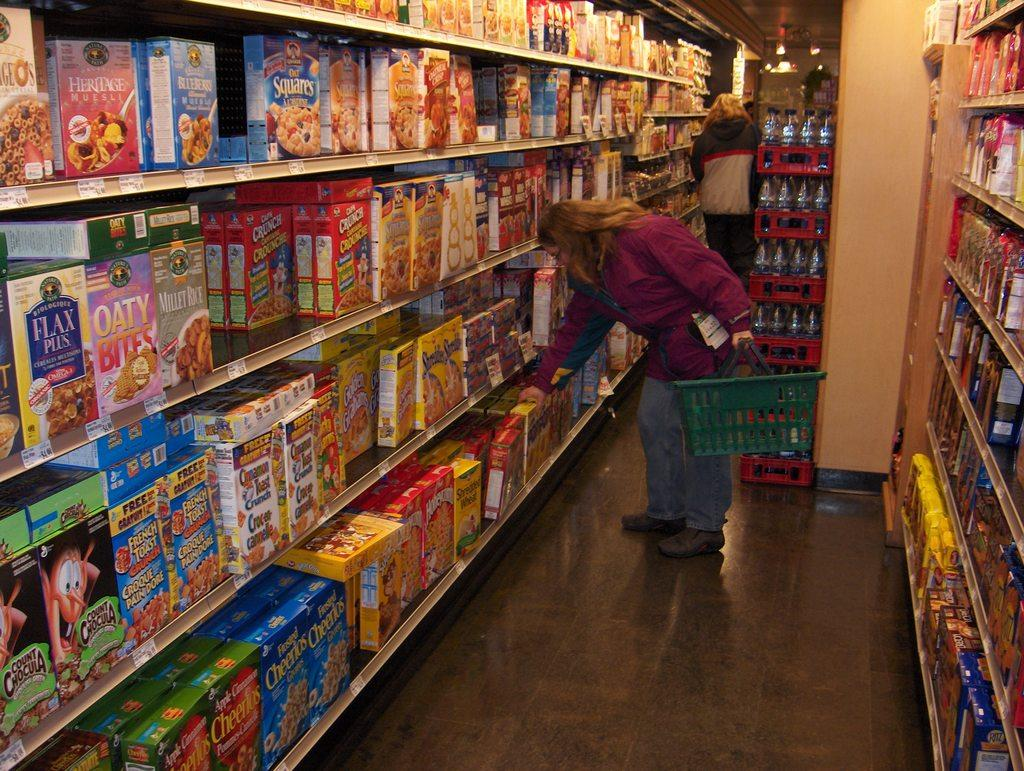Provide a one-sentence caption for the provided image. Person shopping for ceral with one that says "OATY" on the front. 